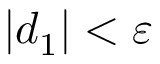<formula> <loc_0><loc_0><loc_500><loc_500>| d _ { 1 } | < \varepsilon</formula> 